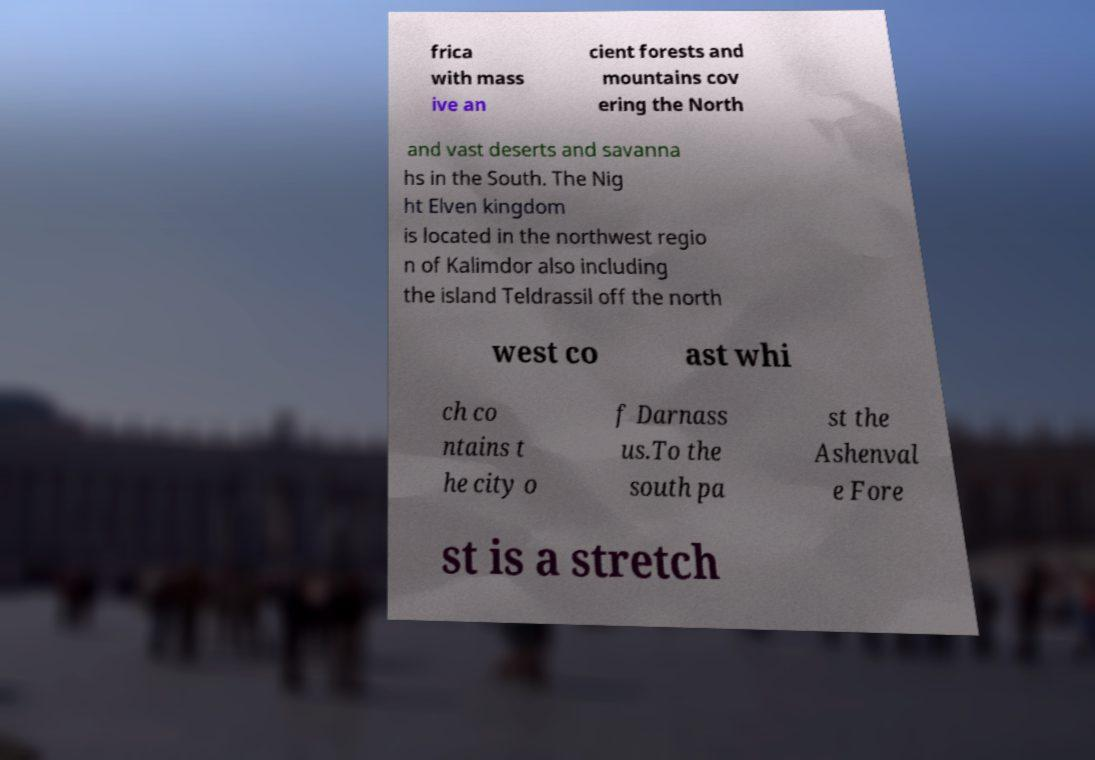Please identify and transcribe the text found in this image. frica with mass ive an cient forests and mountains cov ering the North and vast deserts and savanna hs in the South. The Nig ht Elven kingdom is located in the northwest regio n of Kalimdor also including the island Teldrassil off the north west co ast whi ch co ntains t he city o f Darnass us.To the south pa st the Ashenval e Fore st is a stretch 